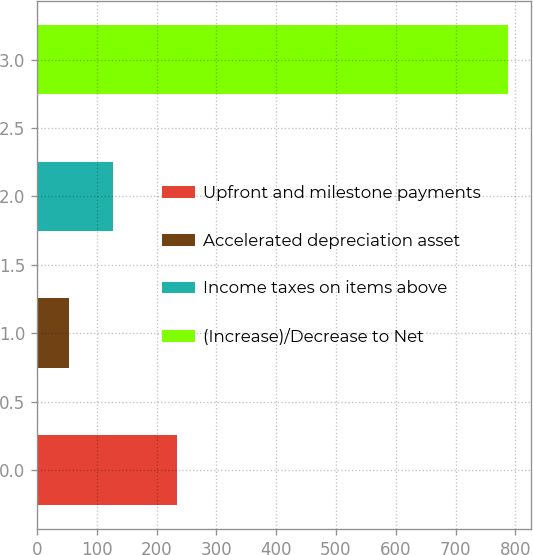Convert chart. <chart><loc_0><loc_0><loc_500><loc_500><bar_chart><fcel>Upfront and milestone payments<fcel>Accelerated depreciation asset<fcel>Income taxes on items above<fcel>(Increase)/Decrease to Net<nl><fcel>235<fcel>54<fcel>127.3<fcel>787<nl></chart> 